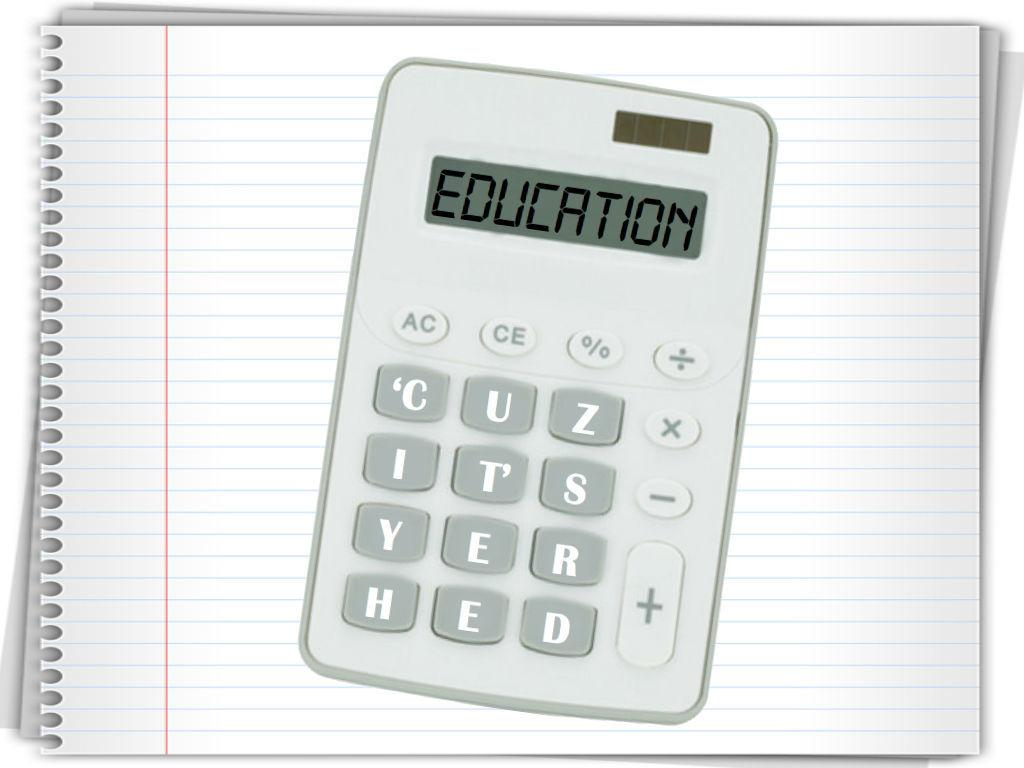Provide a one-sentence caption for the provided image. A small grade calculator has the word education in its read out window. 